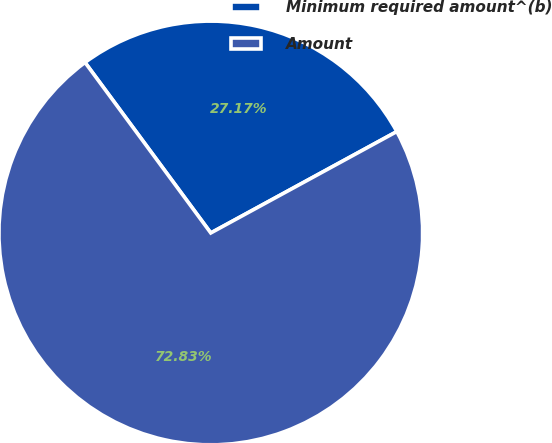<chart> <loc_0><loc_0><loc_500><loc_500><pie_chart><fcel>Minimum required amount^(b)<fcel>Amount<nl><fcel>27.17%<fcel>72.83%<nl></chart> 